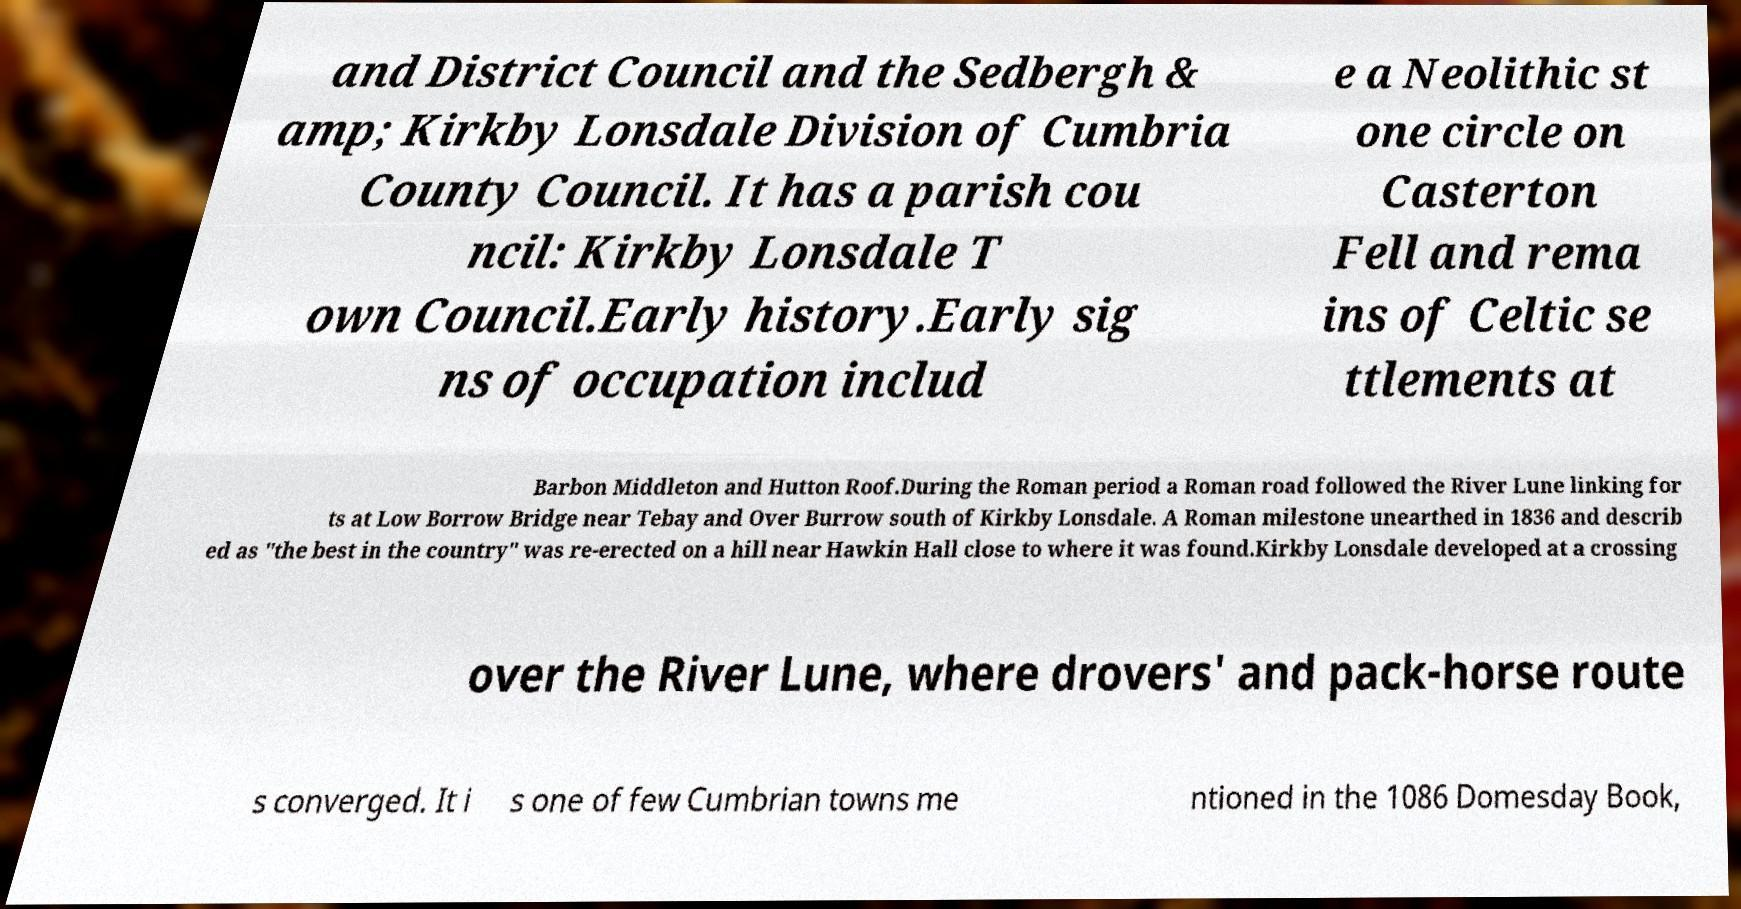For documentation purposes, I need the text within this image transcribed. Could you provide that? and District Council and the Sedbergh & amp; Kirkby Lonsdale Division of Cumbria County Council. It has a parish cou ncil: Kirkby Lonsdale T own Council.Early history.Early sig ns of occupation includ e a Neolithic st one circle on Casterton Fell and rema ins of Celtic se ttlements at Barbon Middleton and Hutton Roof.During the Roman period a Roman road followed the River Lune linking for ts at Low Borrow Bridge near Tebay and Over Burrow south of Kirkby Lonsdale. A Roman milestone unearthed in 1836 and describ ed as "the best in the country" was re-erected on a hill near Hawkin Hall close to where it was found.Kirkby Lonsdale developed at a crossing over the River Lune, where drovers' and pack-horse route s converged. It i s one of few Cumbrian towns me ntioned in the 1086 Domesday Book, 